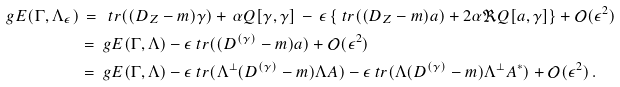Convert formula to latex. <formula><loc_0><loc_0><loc_500><loc_500>\ g E ( \Gamma , \Lambda _ { \epsilon } ) & \, = \, \ t r ( ( D _ { Z } - m ) \gamma ) + \, \alpha Q [ \gamma , \gamma ] \, - \, \epsilon \left \{ \ t r ( ( D _ { Z } - m ) a ) + 2 \alpha \Re Q [ a , \gamma ] \right \} + \mathcal { O } ( \epsilon ^ { 2 } ) \\ & = \ g E ( \Gamma , \Lambda ) - \epsilon \ t r ( ( D ^ { ( \gamma ) } - m ) a ) + \mathcal { O } ( \epsilon ^ { 2 } ) \\ & = \ g E ( \Gamma , \Lambda ) - \epsilon \ t r ( \Lambda ^ { \perp } ( D ^ { ( \gamma ) } - m ) \Lambda A ) - \epsilon \ t r ( \Lambda ( D ^ { ( \gamma ) } - m ) \Lambda ^ { \perp } A ^ { * } ) + \mathcal { O } ( \epsilon ^ { 2 } ) \, .</formula> 